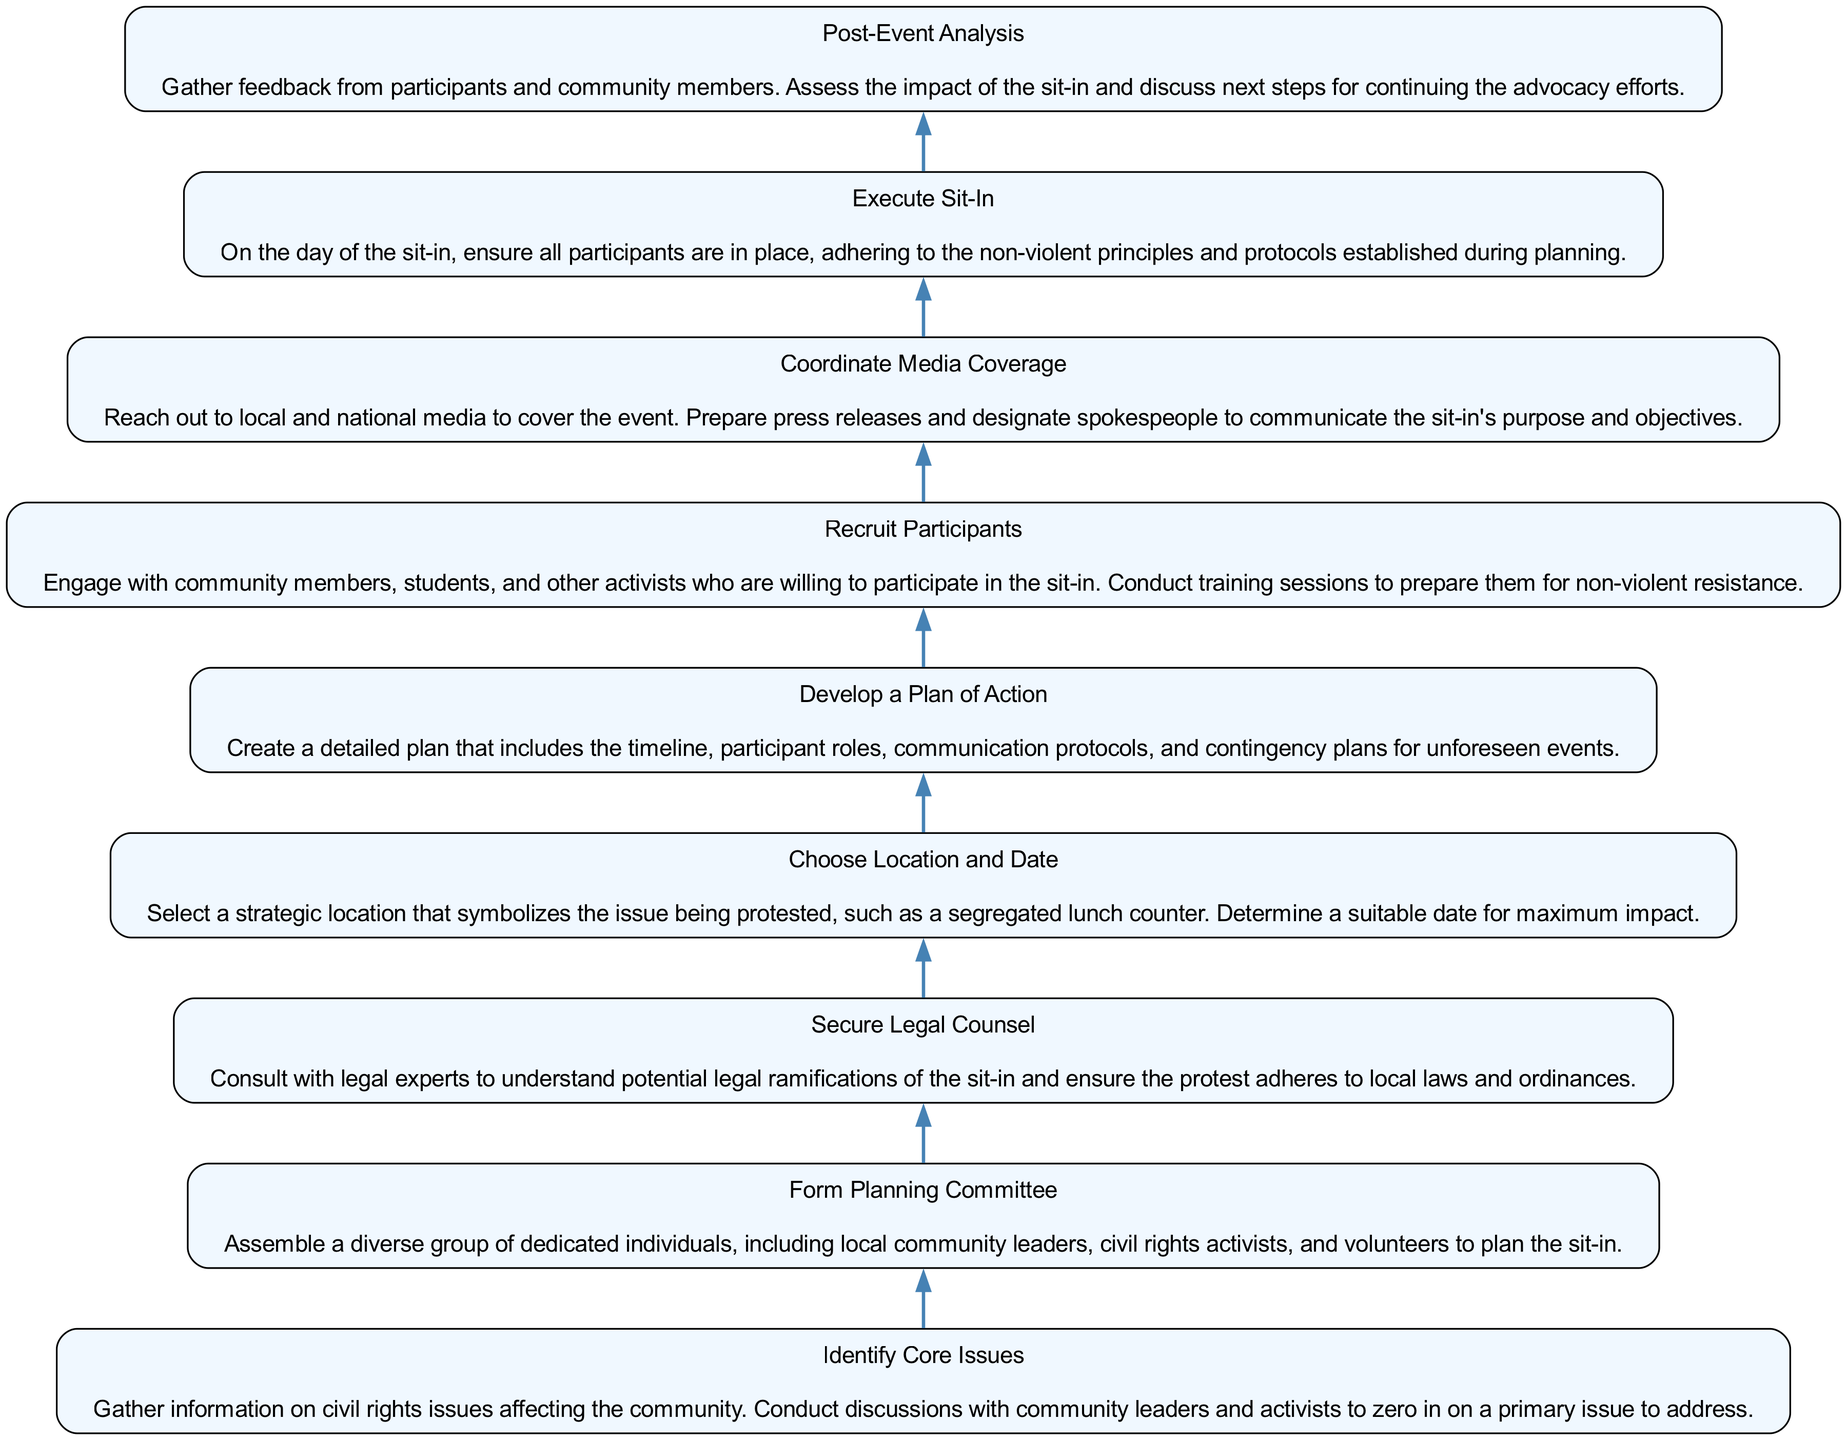What is the first step in the process of organizing a community sit-in? The first step is "Identify Core Issues." This is observed as the bottom-most node in the flow chart, indicating that it's the starting point of the organizing process.
Answer: Identify Core Issues How many steps are there in total for the sit-in organizing process? By counting the number of nodes listed in the diagram, we find there are a total of nine steps, each representing a critical part of the process from planning to execution.
Answer: Nine What comes after "Form Planning Committee"? Referring to the flow of the chart, "Secure Legal Counsel" directly follows "Form Planning Committee," indicating the progression from assembling the committee to ensuring legal guidance.
Answer: Secure Legal Counsel Which step involves interaction with the media? The step that involves interaction with the media is "Coordinate Media Coverage." This node specifically mentions reaching out to local and national media to cover the event.
Answer: Coordinate Media Coverage What is the last step in the sit-in organizing process? The last step in the process is "Post-Event Analysis," as indicated by the topmost position in the flow chart, marking it as the concluding action after the sit-in is executed.
Answer: Post-Event Analysis What is the relationship between "Recruit Participants" and "Execute Sit-In"? "Recruit Participants" precedes "Execute Sit-In;" it plays a crucial role in ensuring enough participants have been prepared and trained before the event takes place. Thus, it’s a necessary step leading directly to execution.
Answer: Precedes How is the "Develop a Plan of Action" step crucial for the overall process? "Develop a Plan of Action" is essential because it outlines timelines, roles, and contingency plans. This structured approach ensures that all participants are aware of their responsibilities and that there is a clear strategy in place leading toward the execution of the sit-in.
Answer: Structured approach What happens immediately before "Choose Location and Date"? Before arriving at "Choose Location and Date," the step that occurs is "Secure Legal Counsel." This indicates that legal considerations are addressed prior to making logistical decisions about the sit-in.
Answer: Secure Legal Counsel Which step emphasizes training for participants? The step that highlights training for participants is "Recruit Participants." It indicates that training sessions are an integral part of ensuring participants are ready for non-violent resistance.
Answer: Recruit Participants 